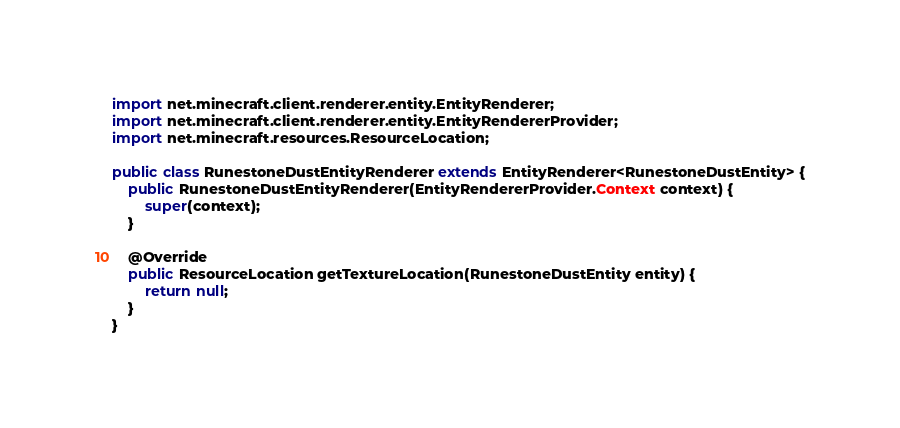Convert code to text. <code><loc_0><loc_0><loc_500><loc_500><_Java_>import net.minecraft.client.renderer.entity.EntityRenderer;
import net.minecraft.client.renderer.entity.EntityRendererProvider;
import net.minecraft.resources.ResourceLocation;

public class RunestoneDustEntityRenderer extends EntityRenderer<RunestoneDustEntity> {
    public RunestoneDustEntityRenderer(EntityRendererProvider.Context context) {
        super(context);
    }

    @Override
    public ResourceLocation getTextureLocation(RunestoneDustEntity entity) {
        return null;
    }
}
</code> 